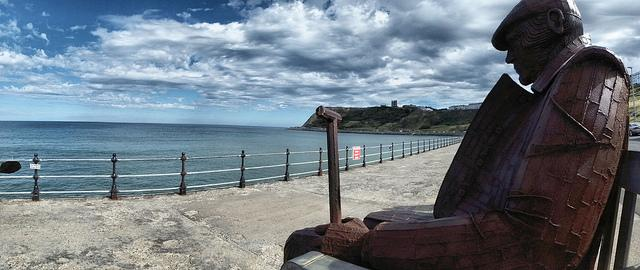What is this man doing? sitting 